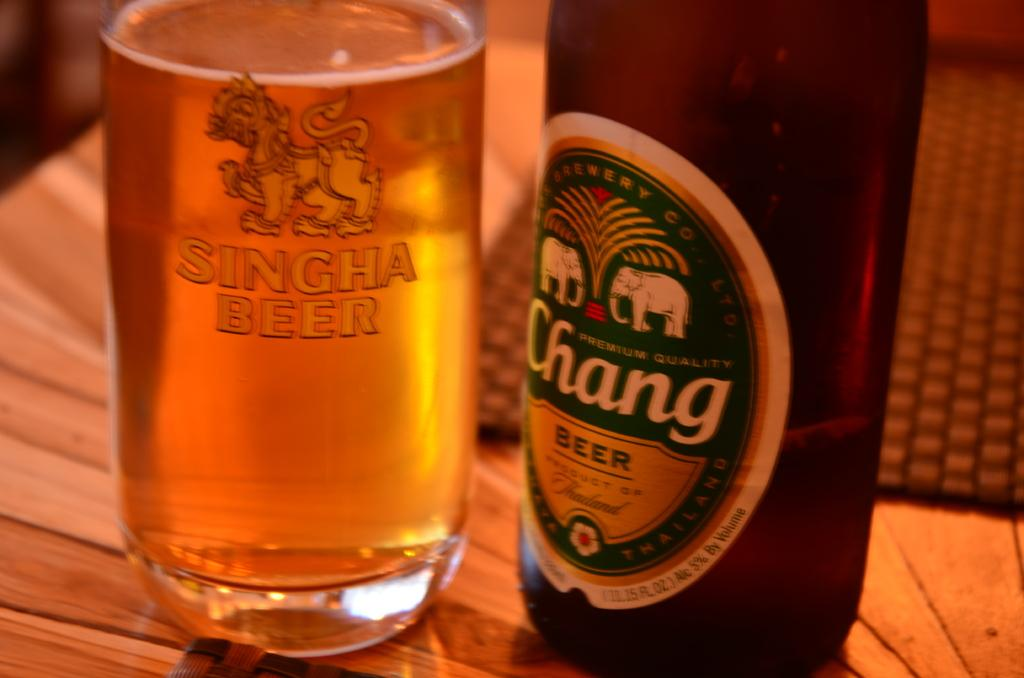<image>
Create a compact narrative representing the image presented. A glass reading Singha Beer next to a bottle of Chang beer. 